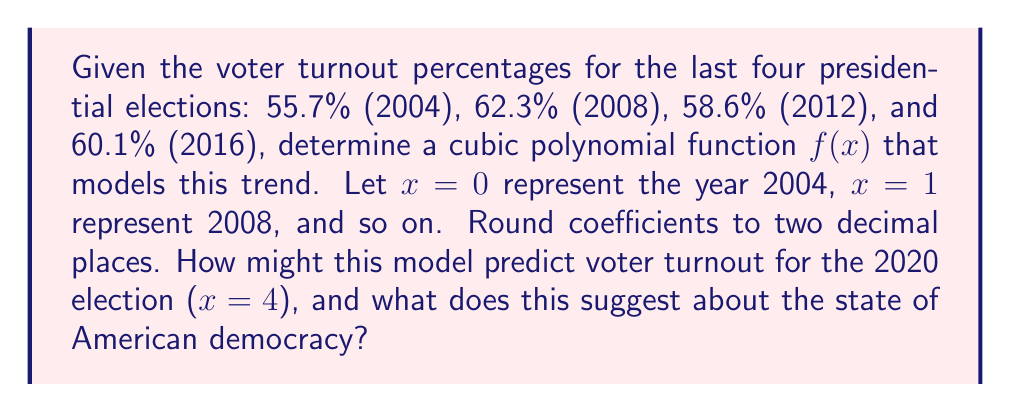Can you answer this question? To find the cubic polynomial function, we'll use the method of finite differences:

1) First, let's organize our data:
   $f(0) = 55.7$
   $f(1) = 62.3$
   $f(2) = 58.6$
   $f(3) = 60.1$

2) Calculate first differences:
   $\Delta f(0) = 62.3 - 55.7 = 6.6$
   $\Delta f(1) = 58.6 - 62.3 = -3.7$
   $\Delta f(2) = 60.1 - 58.6 = 1.5$

3) Calculate second differences:
   $\Delta^2 f(0) = -3.7 - 6.6 = -10.3$
   $\Delta^2 f(1) = 1.5 - (-3.7) = 5.2$

4) Calculate third difference:
   $\Delta^3 f(0) = 5.2 - (-10.3) = 15.5$

5) The cubic function has the form:
   $f(x) = ax^3 + bx^2 + cx + d$

   Where:
   $a = \frac{\Delta^3 f(0)}{6} = \frac{15.5}{6} = 2.58$
   $b = \frac{\Delta^2 f(0)}{2} - \frac{\Delta^3 f(0)}{2} = \frac{-10.3}{2} - \frac{15.5}{2} = -12.9$
   $c = \Delta f(0) - \Delta^2 f(0) - \frac{\Delta^3 f(0)}{2} = 6.6 - (-10.3) - \frac{15.5}{2} = 24.65$
   $d = f(0) = 55.7$

6) Therefore, the cubic function is:
   $f(x) = 2.58x^3 - 12.9x^2 + 24.65x + 55.7$

7) To predict 2020 turnout, calculate $f(4)$:
   $f(4) = 2.58(64) - 12.9(16) + 24.65(4) + 55.7 = 66.06$

This model predicts a 66.06% voter turnout for 2020, suggesting a potential increase in political engagement. However, the volatility in the model reflects the unpredictable nature of voter behavior and the complex factors influencing American democracy.
Answer: $f(x) = 2.58x^3 - 12.9x^2 + 24.65x + 55.7$ 